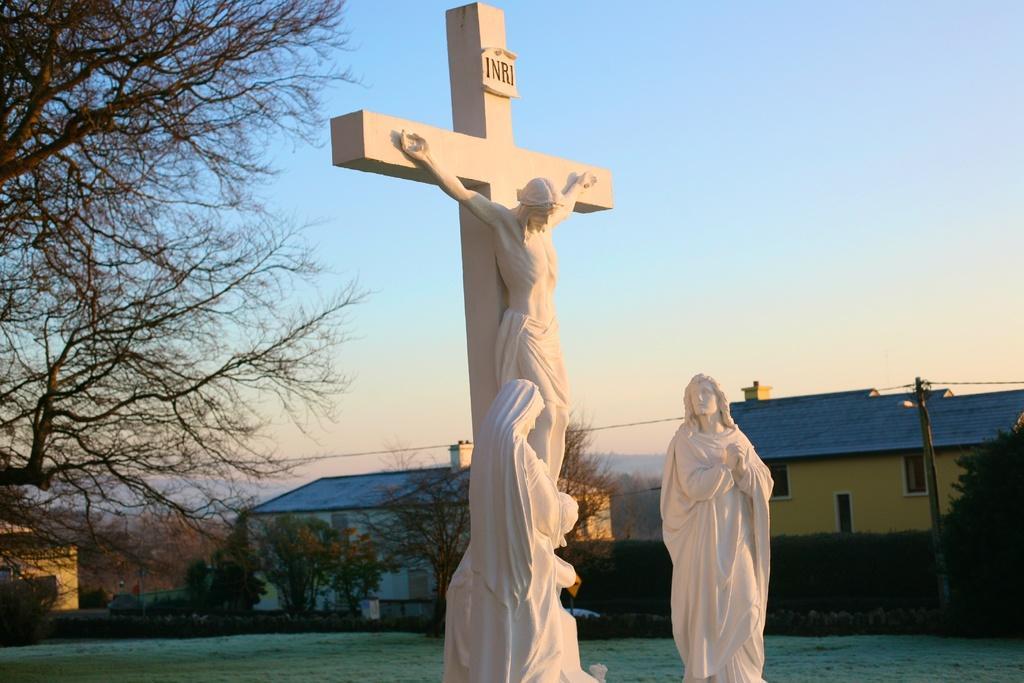Could you give a brief overview of what you see in this image? In this image there is a Jesus statue in the middle. In the background there are buildings. Beside the building there are poles to which there are wires. At the top there is the sky. On the left side there is a tree. On the ground there is grass. 